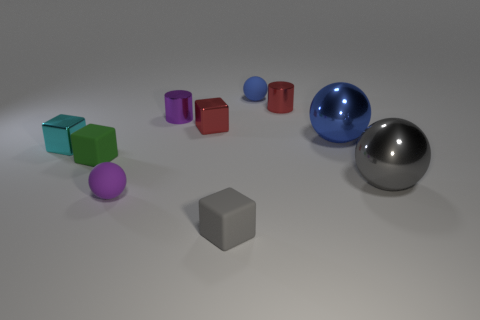Subtract all green cubes. How many blue balls are left? 2 Subtract all blue metal balls. How many balls are left? 3 Subtract all red blocks. How many blocks are left? 3 Subtract all blocks. How many objects are left? 6 Subtract 1 balls. How many balls are left? 3 Subtract all tiny green rubber objects. Subtract all green things. How many objects are left? 8 Add 3 cyan things. How many cyan things are left? 4 Add 3 large red shiny objects. How many large red shiny objects exist? 3 Subtract 0 blue cylinders. How many objects are left? 10 Subtract all cyan balls. Subtract all blue cubes. How many balls are left? 4 